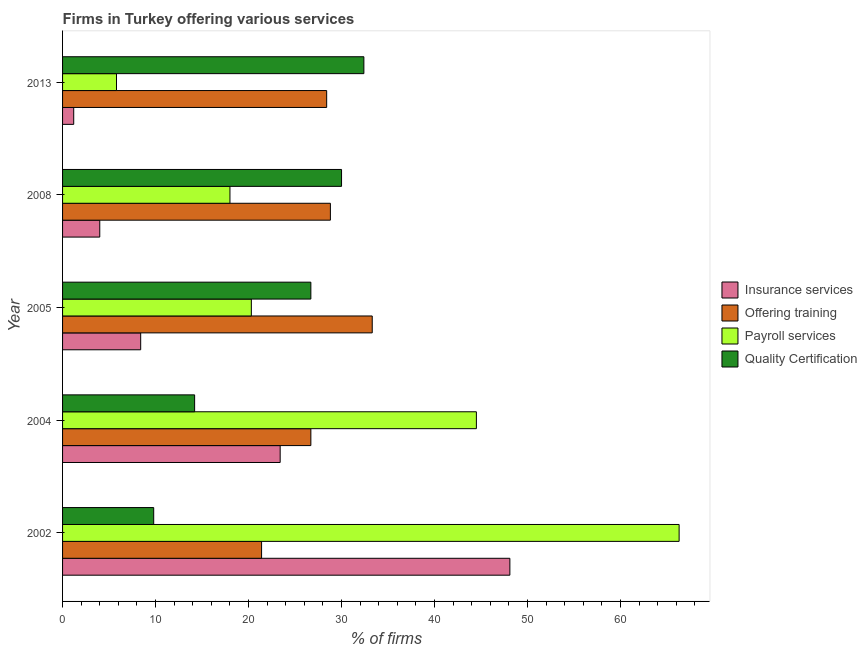Are the number of bars per tick equal to the number of legend labels?
Make the answer very short. Yes. In how many cases, is the number of bars for a given year not equal to the number of legend labels?
Offer a very short reply. 0. What is the percentage of firms offering quality certification in 2002?
Offer a very short reply. 9.8. Across all years, what is the maximum percentage of firms offering quality certification?
Give a very brief answer. 32.4. In which year was the percentage of firms offering training maximum?
Provide a succinct answer. 2005. In which year was the percentage of firms offering training minimum?
Offer a very short reply. 2002. What is the total percentage of firms offering quality certification in the graph?
Your response must be concise. 113.1. What is the difference between the percentage of firms offering payroll services in 2013 and the percentage of firms offering quality certification in 2004?
Make the answer very short. -8.4. What is the average percentage of firms offering insurance services per year?
Provide a short and direct response. 17.02. In the year 2008, what is the difference between the percentage of firms offering payroll services and percentage of firms offering training?
Your response must be concise. -10.8. What is the ratio of the percentage of firms offering training in 2002 to that in 2005?
Provide a succinct answer. 0.64. What is the difference between the highest and the second highest percentage of firms offering insurance services?
Offer a very short reply. 24.7. In how many years, is the percentage of firms offering payroll services greater than the average percentage of firms offering payroll services taken over all years?
Offer a very short reply. 2. Is the sum of the percentage of firms offering insurance services in 2002 and 2008 greater than the maximum percentage of firms offering training across all years?
Offer a terse response. Yes. Is it the case that in every year, the sum of the percentage of firms offering insurance services and percentage of firms offering quality certification is greater than the sum of percentage of firms offering training and percentage of firms offering payroll services?
Make the answer very short. Yes. What does the 1st bar from the top in 2005 represents?
Your answer should be very brief. Quality Certification. What does the 4th bar from the bottom in 2013 represents?
Offer a terse response. Quality Certification. Is it the case that in every year, the sum of the percentage of firms offering insurance services and percentage of firms offering training is greater than the percentage of firms offering payroll services?
Provide a short and direct response. Yes. Are all the bars in the graph horizontal?
Your response must be concise. Yes. How many years are there in the graph?
Provide a succinct answer. 5. Does the graph contain grids?
Keep it short and to the point. No. Where does the legend appear in the graph?
Make the answer very short. Center right. What is the title of the graph?
Give a very brief answer. Firms in Turkey offering various services . What is the label or title of the X-axis?
Keep it short and to the point. % of firms. What is the % of firms of Insurance services in 2002?
Offer a terse response. 48.1. What is the % of firms in Offering training in 2002?
Ensure brevity in your answer.  21.4. What is the % of firms in Payroll services in 2002?
Make the answer very short. 66.3. What is the % of firms of Insurance services in 2004?
Provide a short and direct response. 23.4. What is the % of firms of Offering training in 2004?
Provide a short and direct response. 26.7. What is the % of firms in Payroll services in 2004?
Ensure brevity in your answer.  44.5. What is the % of firms in Quality Certification in 2004?
Your answer should be compact. 14.2. What is the % of firms in Insurance services in 2005?
Your response must be concise. 8.4. What is the % of firms in Offering training in 2005?
Keep it short and to the point. 33.3. What is the % of firms in Payroll services in 2005?
Offer a very short reply. 20.3. What is the % of firms in Quality Certification in 2005?
Give a very brief answer. 26.7. What is the % of firms in Offering training in 2008?
Make the answer very short. 28.8. What is the % of firms of Quality Certification in 2008?
Keep it short and to the point. 30. What is the % of firms in Offering training in 2013?
Provide a short and direct response. 28.4. What is the % of firms of Quality Certification in 2013?
Make the answer very short. 32.4. Across all years, what is the maximum % of firms in Insurance services?
Your response must be concise. 48.1. Across all years, what is the maximum % of firms of Offering training?
Your answer should be very brief. 33.3. Across all years, what is the maximum % of firms of Payroll services?
Give a very brief answer. 66.3. Across all years, what is the maximum % of firms in Quality Certification?
Your response must be concise. 32.4. Across all years, what is the minimum % of firms of Insurance services?
Give a very brief answer. 1.2. Across all years, what is the minimum % of firms in Offering training?
Your answer should be very brief. 21.4. What is the total % of firms of Insurance services in the graph?
Your answer should be very brief. 85.1. What is the total % of firms of Offering training in the graph?
Offer a terse response. 138.6. What is the total % of firms in Payroll services in the graph?
Provide a short and direct response. 154.9. What is the total % of firms in Quality Certification in the graph?
Give a very brief answer. 113.1. What is the difference between the % of firms in Insurance services in 2002 and that in 2004?
Your answer should be very brief. 24.7. What is the difference between the % of firms in Offering training in 2002 and that in 2004?
Give a very brief answer. -5.3. What is the difference between the % of firms of Payroll services in 2002 and that in 2004?
Provide a succinct answer. 21.8. What is the difference between the % of firms in Insurance services in 2002 and that in 2005?
Provide a short and direct response. 39.7. What is the difference between the % of firms of Offering training in 2002 and that in 2005?
Make the answer very short. -11.9. What is the difference between the % of firms in Quality Certification in 2002 and that in 2005?
Provide a short and direct response. -16.9. What is the difference between the % of firms of Insurance services in 2002 and that in 2008?
Give a very brief answer. 44.1. What is the difference between the % of firms of Payroll services in 2002 and that in 2008?
Ensure brevity in your answer.  48.3. What is the difference between the % of firms of Quality Certification in 2002 and that in 2008?
Your response must be concise. -20.2. What is the difference between the % of firms in Insurance services in 2002 and that in 2013?
Your answer should be very brief. 46.9. What is the difference between the % of firms in Offering training in 2002 and that in 2013?
Provide a short and direct response. -7. What is the difference between the % of firms of Payroll services in 2002 and that in 2013?
Keep it short and to the point. 60.5. What is the difference between the % of firms of Quality Certification in 2002 and that in 2013?
Keep it short and to the point. -22.6. What is the difference between the % of firms in Payroll services in 2004 and that in 2005?
Provide a succinct answer. 24.2. What is the difference between the % of firms in Quality Certification in 2004 and that in 2005?
Your answer should be very brief. -12.5. What is the difference between the % of firms in Offering training in 2004 and that in 2008?
Give a very brief answer. -2.1. What is the difference between the % of firms in Quality Certification in 2004 and that in 2008?
Your answer should be very brief. -15.8. What is the difference between the % of firms of Offering training in 2004 and that in 2013?
Your response must be concise. -1.7. What is the difference between the % of firms of Payroll services in 2004 and that in 2013?
Make the answer very short. 38.7. What is the difference between the % of firms of Quality Certification in 2004 and that in 2013?
Offer a terse response. -18.2. What is the difference between the % of firms of Insurance services in 2005 and that in 2008?
Make the answer very short. 4.4. What is the difference between the % of firms of Offering training in 2005 and that in 2008?
Give a very brief answer. 4.5. What is the difference between the % of firms of Offering training in 2005 and that in 2013?
Your response must be concise. 4.9. What is the difference between the % of firms in Insurance services in 2008 and that in 2013?
Make the answer very short. 2.8. What is the difference between the % of firms in Offering training in 2008 and that in 2013?
Give a very brief answer. 0.4. What is the difference between the % of firms of Insurance services in 2002 and the % of firms of Offering training in 2004?
Your answer should be compact. 21.4. What is the difference between the % of firms of Insurance services in 2002 and the % of firms of Payroll services in 2004?
Offer a very short reply. 3.6. What is the difference between the % of firms of Insurance services in 2002 and the % of firms of Quality Certification in 2004?
Your response must be concise. 33.9. What is the difference between the % of firms in Offering training in 2002 and the % of firms in Payroll services in 2004?
Your answer should be very brief. -23.1. What is the difference between the % of firms in Payroll services in 2002 and the % of firms in Quality Certification in 2004?
Offer a terse response. 52.1. What is the difference between the % of firms of Insurance services in 2002 and the % of firms of Offering training in 2005?
Your answer should be compact. 14.8. What is the difference between the % of firms of Insurance services in 2002 and the % of firms of Payroll services in 2005?
Ensure brevity in your answer.  27.8. What is the difference between the % of firms in Insurance services in 2002 and the % of firms in Quality Certification in 2005?
Your answer should be very brief. 21.4. What is the difference between the % of firms of Offering training in 2002 and the % of firms of Payroll services in 2005?
Ensure brevity in your answer.  1.1. What is the difference between the % of firms of Payroll services in 2002 and the % of firms of Quality Certification in 2005?
Make the answer very short. 39.6. What is the difference between the % of firms in Insurance services in 2002 and the % of firms in Offering training in 2008?
Offer a very short reply. 19.3. What is the difference between the % of firms of Insurance services in 2002 and the % of firms of Payroll services in 2008?
Your response must be concise. 30.1. What is the difference between the % of firms in Payroll services in 2002 and the % of firms in Quality Certification in 2008?
Give a very brief answer. 36.3. What is the difference between the % of firms of Insurance services in 2002 and the % of firms of Offering training in 2013?
Ensure brevity in your answer.  19.7. What is the difference between the % of firms in Insurance services in 2002 and the % of firms in Payroll services in 2013?
Your answer should be compact. 42.3. What is the difference between the % of firms of Offering training in 2002 and the % of firms of Quality Certification in 2013?
Your response must be concise. -11. What is the difference between the % of firms of Payroll services in 2002 and the % of firms of Quality Certification in 2013?
Offer a very short reply. 33.9. What is the difference between the % of firms in Insurance services in 2004 and the % of firms in Offering training in 2005?
Your response must be concise. -9.9. What is the difference between the % of firms of Insurance services in 2004 and the % of firms of Payroll services in 2005?
Ensure brevity in your answer.  3.1. What is the difference between the % of firms of Insurance services in 2004 and the % of firms of Quality Certification in 2005?
Offer a terse response. -3.3. What is the difference between the % of firms in Offering training in 2004 and the % of firms in Payroll services in 2005?
Keep it short and to the point. 6.4. What is the difference between the % of firms of Payroll services in 2004 and the % of firms of Quality Certification in 2005?
Your response must be concise. 17.8. What is the difference between the % of firms of Offering training in 2004 and the % of firms of Payroll services in 2008?
Give a very brief answer. 8.7. What is the difference between the % of firms in Offering training in 2004 and the % of firms in Quality Certification in 2008?
Give a very brief answer. -3.3. What is the difference between the % of firms of Insurance services in 2004 and the % of firms of Quality Certification in 2013?
Offer a very short reply. -9. What is the difference between the % of firms of Offering training in 2004 and the % of firms of Payroll services in 2013?
Make the answer very short. 20.9. What is the difference between the % of firms in Payroll services in 2004 and the % of firms in Quality Certification in 2013?
Your response must be concise. 12.1. What is the difference between the % of firms in Insurance services in 2005 and the % of firms in Offering training in 2008?
Your answer should be compact. -20.4. What is the difference between the % of firms of Insurance services in 2005 and the % of firms of Quality Certification in 2008?
Offer a very short reply. -21.6. What is the difference between the % of firms in Insurance services in 2005 and the % of firms in Offering training in 2013?
Keep it short and to the point. -20. What is the difference between the % of firms of Insurance services in 2005 and the % of firms of Payroll services in 2013?
Ensure brevity in your answer.  2.6. What is the difference between the % of firms of Insurance services in 2005 and the % of firms of Quality Certification in 2013?
Your answer should be very brief. -24. What is the difference between the % of firms in Insurance services in 2008 and the % of firms in Offering training in 2013?
Your response must be concise. -24.4. What is the difference between the % of firms in Insurance services in 2008 and the % of firms in Quality Certification in 2013?
Your answer should be compact. -28.4. What is the difference between the % of firms of Offering training in 2008 and the % of firms of Payroll services in 2013?
Provide a short and direct response. 23. What is the difference between the % of firms in Offering training in 2008 and the % of firms in Quality Certification in 2013?
Ensure brevity in your answer.  -3.6. What is the difference between the % of firms of Payroll services in 2008 and the % of firms of Quality Certification in 2013?
Keep it short and to the point. -14.4. What is the average % of firms of Insurance services per year?
Make the answer very short. 17.02. What is the average % of firms of Offering training per year?
Give a very brief answer. 27.72. What is the average % of firms in Payroll services per year?
Ensure brevity in your answer.  30.98. What is the average % of firms in Quality Certification per year?
Your answer should be very brief. 22.62. In the year 2002, what is the difference between the % of firms in Insurance services and % of firms in Offering training?
Your answer should be compact. 26.7. In the year 2002, what is the difference between the % of firms in Insurance services and % of firms in Payroll services?
Offer a very short reply. -18.2. In the year 2002, what is the difference between the % of firms of Insurance services and % of firms of Quality Certification?
Offer a very short reply. 38.3. In the year 2002, what is the difference between the % of firms of Offering training and % of firms of Payroll services?
Provide a succinct answer. -44.9. In the year 2002, what is the difference between the % of firms in Payroll services and % of firms in Quality Certification?
Your answer should be compact. 56.5. In the year 2004, what is the difference between the % of firms in Insurance services and % of firms in Offering training?
Offer a very short reply. -3.3. In the year 2004, what is the difference between the % of firms of Insurance services and % of firms of Payroll services?
Ensure brevity in your answer.  -21.1. In the year 2004, what is the difference between the % of firms in Insurance services and % of firms in Quality Certification?
Your answer should be very brief. 9.2. In the year 2004, what is the difference between the % of firms in Offering training and % of firms in Payroll services?
Your answer should be very brief. -17.8. In the year 2004, what is the difference between the % of firms in Payroll services and % of firms in Quality Certification?
Offer a terse response. 30.3. In the year 2005, what is the difference between the % of firms of Insurance services and % of firms of Offering training?
Your answer should be very brief. -24.9. In the year 2005, what is the difference between the % of firms in Insurance services and % of firms in Payroll services?
Offer a terse response. -11.9. In the year 2005, what is the difference between the % of firms of Insurance services and % of firms of Quality Certification?
Provide a succinct answer. -18.3. In the year 2008, what is the difference between the % of firms of Insurance services and % of firms of Offering training?
Keep it short and to the point. -24.8. In the year 2013, what is the difference between the % of firms of Insurance services and % of firms of Offering training?
Your answer should be compact. -27.2. In the year 2013, what is the difference between the % of firms in Insurance services and % of firms in Payroll services?
Make the answer very short. -4.6. In the year 2013, what is the difference between the % of firms in Insurance services and % of firms in Quality Certification?
Provide a short and direct response. -31.2. In the year 2013, what is the difference between the % of firms in Offering training and % of firms in Payroll services?
Give a very brief answer. 22.6. In the year 2013, what is the difference between the % of firms in Offering training and % of firms in Quality Certification?
Your answer should be compact. -4. In the year 2013, what is the difference between the % of firms of Payroll services and % of firms of Quality Certification?
Your response must be concise. -26.6. What is the ratio of the % of firms of Insurance services in 2002 to that in 2004?
Your response must be concise. 2.06. What is the ratio of the % of firms in Offering training in 2002 to that in 2004?
Make the answer very short. 0.8. What is the ratio of the % of firms of Payroll services in 2002 to that in 2004?
Your response must be concise. 1.49. What is the ratio of the % of firms of Quality Certification in 2002 to that in 2004?
Your response must be concise. 0.69. What is the ratio of the % of firms in Insurance services in 2002 to that in 2005?
Offer a terse response. 5.73. What is the ratio of the % of firms of Offering training in 2002 to that in 2005?
Offer a very short reply. 0.64. What is the ratio of the % of firms in Payroll services in 2002 to that in 2005?
Provide a short and direct response. 3.27. What is the ratio of the % of firms of Quality Certification in 2002 to that in 2005?
Give a very brief answer. 0.37. What is the ratio of the % of firms in Insurance services in 2002 to that in 2008?
Make the answer very short. 12.03. What is the ratio of the % of firms in Offering training in 2002 to that in 2008?
Ensure brevity in your answer.  0.74. What is the ratio of the % of firms of Payroll services in 2002 to that in 2008?
Provide a short and direct response. 3.68. What is the ratio of the % of firms in Quality Certification in 2002 to that in 2008?
Your answer should be compact. 0.33. What is the ratio of the % of firms in Insurance services in 2002 to that in 2013?
Provide a short and direct response. 40.08. What is the ratio of the % of firms in Offering training in 2002 to that in 2013?
Keep it short and to the point. 0.75. What is the ratio of the % of firms of Payroll services in 2002 to that in 2013?
Offer a terse response. 11.43. What is the ratio of the % of firms in Quality Certification in 2002 to that in 2013?
Offer a terse response. 0.3. What is the ratio of the % of firms in Insurance services in 2004 to that in 2005?
Your answer should be compact. 2.79. What is the ratio of the % of firms in Offering training in 2004 to that in 2005?
Provide a short and direct response. 0.8. What is the ratio of the % of firms of Payroll services in 2004 to that in 2005?
Ensure brevity in your answer.  2.19. What is the ratio of the % of firms in Quality Certification in 2004 to that in 2005?
Give a very brief answer. 0.53. What is the ratio of the % of firms in Insurance services in 2004 to that in 2008?
Ensure brevity in your answer.  5.85. What is the ratio of the % of firms in Offering training in 2004 to that in 2008?
Make the answer very short. 0.93. What is the ratio of the % of firms of Payroll services in 2004 to that in 2008?
Make the answer very short. 2.47. What is the ratio of the % of firms of Quality Certification in 2004 to that in 2008?
Offer a very short reply. 0.47. What is the ratio of the % of firms in Insurance services in 2004 to that in 2013?
Give a very brief answer. 19.5. What is the ratio of the % of firms in Offering training in 2004 to that in 2013?
Your answer should be compact. 0.94. What is the ratio of the % of firms in Payroll services in 2004 to that in 2013?
Ensure brevity in your answer.  7.67. What is the ratio of the % of firms in Quality Certification in 2004 to that in 2013?
Provide a succinct answer. 0.44. What is the ratio of the % of firms in Insurance services in 2005 to that in 2008?
Offer a very short reply. 2.1. What is the ratio of the % of firms in Offering training in 2005 to that in 2008?
Provide a short and direct response. 1.16. What is the ratio of the % of firms in Payroll services in 2005 to that in 2008?
Ensure brevity in your answer.  1.13. What is the ratio of the % of firms in Quality Certification in 2005 to that in 2008?
Ensure brevity in your answer.  0.89. What is the ratio of the % of firms in Insurance services in 2005 to that in 2013?
Provide a succinct answer. 7. What is the ratio of the % of firms in Offering training in 2005 to that in 2013?
Your answer should be very brief. 1.17. What is the ratio of the % of firms in Quality Certification in 2005 to that in 2013?
Make the answer very short. 0.82. What is the ratio of the % of firms of Insurance services in 2008 to that in 2013?
Make the answer very short. 3.33. What is the ratio of the % of firms of Offering training in 2008 to that in 2013?
Your answer should be very brief. 1.01. What is the ratio of the % of firms of Payroll services in 2008 to that in 2013?
Provide a succinct answer. 3.1. What is the ratio of the % of firms of Quality Certification in 2008 to that in 2013?
Your answer should be compact. 0.93. What is the difference between the highest and the second highest % of firms in Insurance services?
Give a very brief answer. 24.7. What is the difference between the highest and the second highest % of firms of Offering training?
Provide a short and direct response. 4.5. What is the difference between the highest and the second highest % of firms in Payroll services?
Give a very brief answer. 21.8. What is the difference between the highest and the lowest % of firms in Insurance services?
Keep it short and to the point. 46.9. What is the difference between the highest and the lowest % of firms of Offering training?
Your response must be concise. 11.9. What is the difference between the highest and the lowest % of firms of Payroll services?
Provide a succinct answer. 60.5. What is the difference between the highest and the lowest % of firms of Quality Certification?
Offer a very short reply. 22.6. 